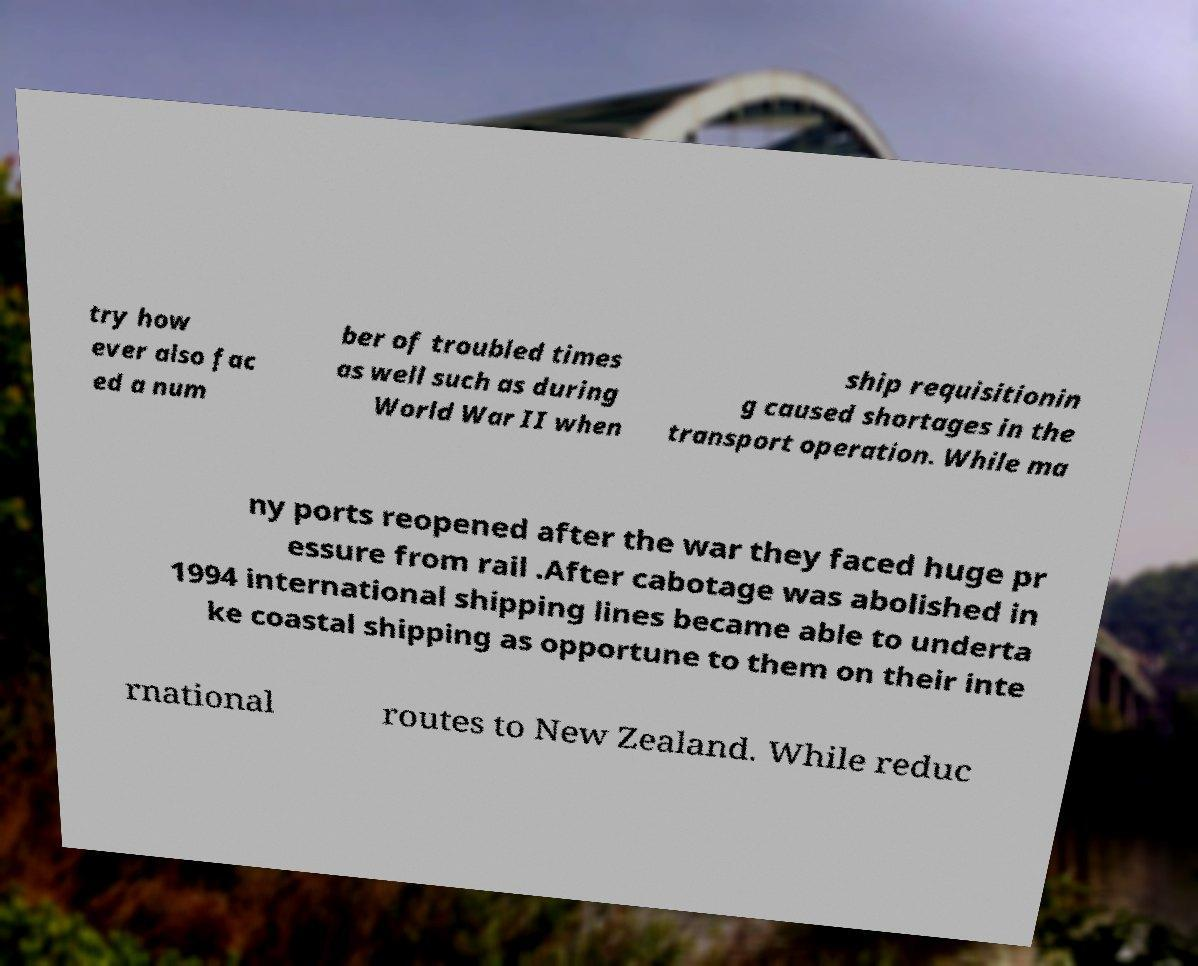For documentation purposes, I need the text within this image transcribed. Could you provide that? try how ever also fac ed a num ber of troubled times as well such as during World War II when ship requisitionin g caused shortages in the transport operation. While ma ny ports reopened after the war they faced huge pr essure from rail .After cabotage was abolished in 1994 international shipping lines became able to underta ke coastal shipping as opportune to them on their inte rnational routes to New Zealand. While reduc 